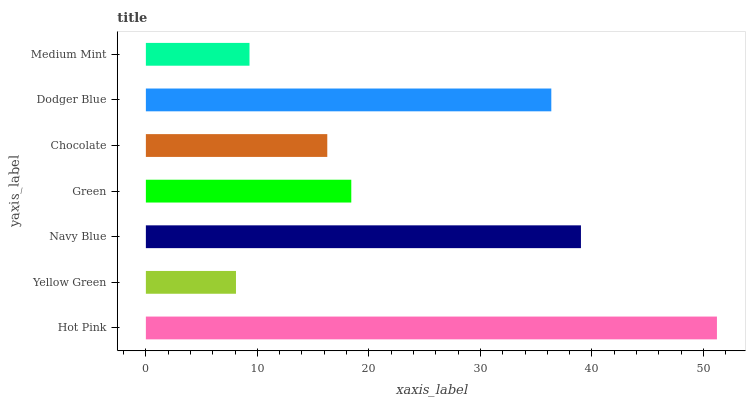Is Yellow Green the minimum?
Answer yes or no. Yes. Is Hot Pink the maximum?
Answer yes or no. Yes. Is Navy Blue the minimum?
Answer yes or no. No. Is Navy Blue the maximum?
Answer yes or no. No. Is Navy Blue greater than Yellow Green?
Answer yes or no. Yes. Is Yellow Green less than Navy Blue?
Answer yes or no. Yes. Is Yellow Green greater than Navy Blue?
Answer yes or no. No. Is Navy Blue less than Yellow Green?
Answer yes or no. No. Is Green the high median?
Answer yes or no. Yes. Is Green the low median?
Answer yes or no. Yes. Is Hot Pink the high median?
Answer yes or no. No. Is Navy Blue the low median?
Answer yes or no. No. 